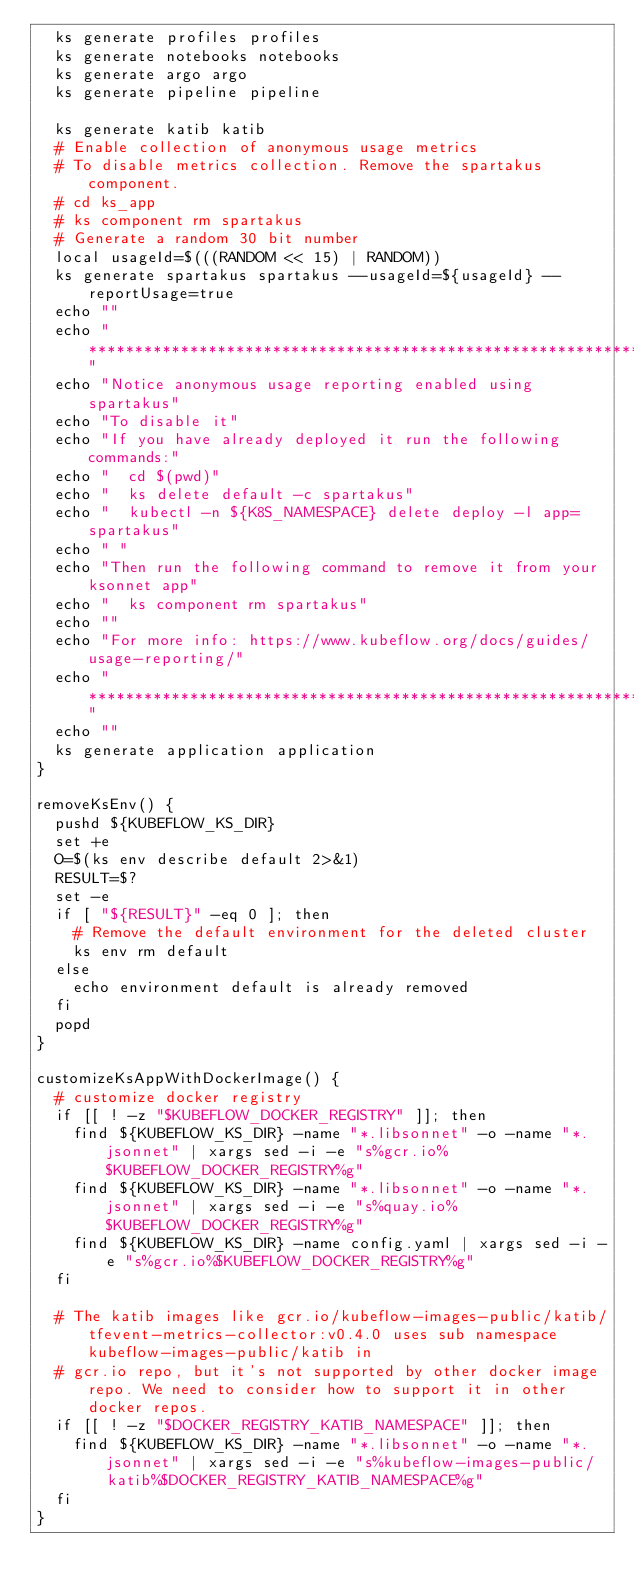Convert code to text. <code><loc_0><loc_0><loc_500><loc_500><_Bash_>  ks generate profiles profiles
  ks generate notebooks notebooks 
  ks generate argo argo
  ks generate pipeline pipeline

  ks generate katib katib
  # Enable collection of anonymous usage metrics
  # To disable metrics collection. Remove the spartakus component.
  # cd ks_app
  # ks component rm spartakus
  # Generate a random 30 bit number
  local usageId=$(((RANDOM << 15) | RANDOM))
  ks generate spartakus spartakus --usageId=${usageId} --reportUsage=true
  echo ""
  echo "****************************************************************"
  echo "Notice anonymous usage reporting enabled using spartakus"
  echo "To disable it"
  echo "If you have already deployed it run the following commands:"
  echo "  cd $(pwd)"
  echo "  ks delete default -c spartakus"
  echo "  kubectl -n ${K8S_NAMESPACE} delete deploy -l app=spartakus"
  echo " "
  echo "Then run the following command to remove it from your ksonnet app"
  echo "  ks component rm spartakus"
  echo ""
  echo "For more info: https://www.kubeflow.org/docs/guides/usage-reporting/"
  echo "****************************************************************"
  echo ""
  ks generate application application
}

removeKsEnv() {
  pushd ${KUBEFLOW_KS_DIR}
  set +e
  O=$(ks env describe default 2>&1)
  RESULT=$?
  set -e
  if [ "${RESULT}" -eq 0 ]; then
    # Remove the default environment for the deleted cluster
    ks env rm default
  else
    echo environment default is already removed
  fi
  popd
}

customizeKsAppWithDockerImage() {
  # customize docker registry
  if [[ ! -z "$KUBEFLOW_DOCKER_REGISTRY" ]]; then
    find ${KUBEFLOW_KS_DIR} -name "*.libsonnet" -o -name "*.jsonnet" | xargs sed -i -e "s%gcr.io%$KUBEFLOW_DOCKER_REGISTRY%g"
    find ${KUBEFLOW_KS_DIR} -name "*.libsonnet" -o -name "*.jsonnet" | xargs sed -i -e "s%quay.io%$KUBEFLOW_DOCKER_REGISTRY%g"
    find ${KUBEFLOW_KS_DIR} -name config.yaml | xargs sed -i -e "s%gcr.io%$KUBEFLOW_DOCKER_REGISTRY%g"
  fi

  # The katib images like gcr.io/kubeflow-images-public/katib/tfevent-metrics-collector:v0.4.0 uses sub namespace kubeflow-images-public/katib in 
  # gcr.io repo, but it's not supported by other docker image repo. We need to consider how to support it in other docker repos.
  if [[ ! -z "$DOCKER_REGISTRY_KATIB_NAMESPACE" ]]; then
    find ${KUBEFLOW_KS_DIR} -name "*.libsonnet" -o -name "*.jsonnet" | xargs sed -i -e "s%kubeflow-images-public/katib%$DOCKER_REGISTRY_KATIB_NAMESPACE%g"
  fi
}
</code> 